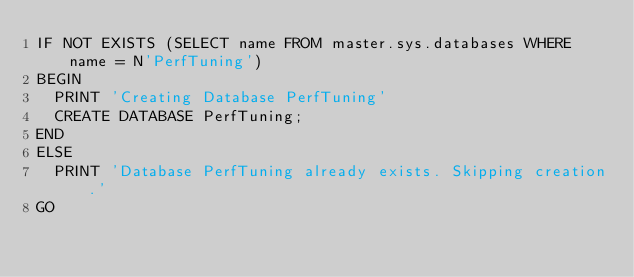<code> <loc_0><loc_0><loc_500><loc_500><_SQL_>IF NOT EXISTS (SELECT name FROM master.sys.databases WHERE name = N'PerfTuning')
BEGIN
  PRINT 'Creating Database PerfTuning'
  CREATE DATABASE PerfTuning;
END
ELSE
  PRINT 'Database PerfTuning already exists. Skipping creation.'
GO
</code> 